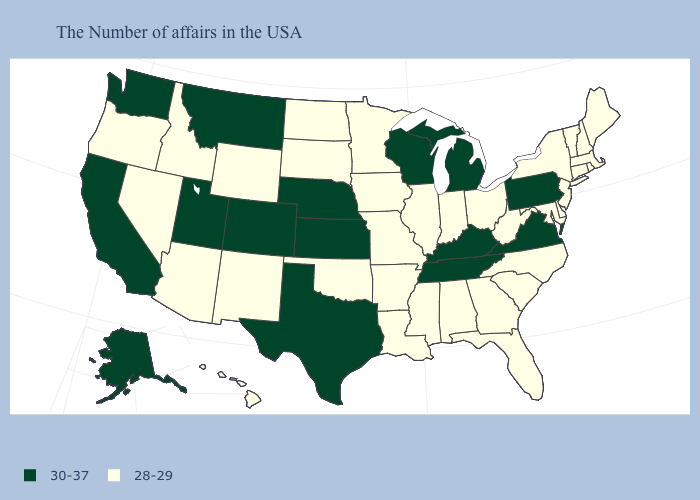What is the value of Indiana?
Quick response, please. 28-29. What is the value of New York?
Keep it brief. 28-29. Does North Carolina have the lowest value in the USA?
Keep it brief. Yes. What is the value of Illinois?
Answer briefly. 28-29. Name the states that have a value in the range 30-37?
Short answer required. Pennsylvania, Virginia, Michigan, Kentucky, Tennessee, Wisconsin, Kansas, Nebraska, Texas, Colorado, Utah, Montana, California, Washington, Alaska. Does South Dakota have a lower value than Virginia?
Answer briefly. Yes. What is the value of New Jersey?
Answer briefly. 28-29. Name the states that have a value in the range 28-29?
Keep it brief. Maine, Massachusetts, Rhode Island, New Hampshire, Vermont, Connecticut, New York, New Jersey, Delaware, Maryland, North Carolina, South Carolina, West Virginia, Ohio, Florida, Georgia, Indiana, Alabama, Illinois, Mississippi, Louisiana, Missouri, Arkansas, Minnesota, Iowa, Oklahoma, South Dakota, North Dakota, Wyoming, New Mexico, Arizona, Idaho, Nevada, Oregon, Hawaii. Does Maine have a lower value than Pennsylvania?
Be succinct. Yes. What is the value of New Jersey?
Write a very short answer. 28-29. Does Alaska have the highest value in the West?
Answer briefly. Yes. Which states hav the highest value in the South?
Keep it brief. Virginia, Kentucky, Tennessee, Texas. Name the states that have a value in the range 30-37?
Keep it brief. Pennsylvania, Virginia, Michigan, Kentucky, Tennessee, Wisconsin, Kansas, Nebraska, Texas, Colorado, Utah, Montana, California, Washington, Alaska. Name the states that have a value in the range 30-37?
Keep it brief. Pennsylvania, Virginia, Michigan, Kentucky, Tennessee, Wisconsin, Kansas, Nebraska, Texas, Colorado, Utah, Montana, California, Washington, Alaska. 